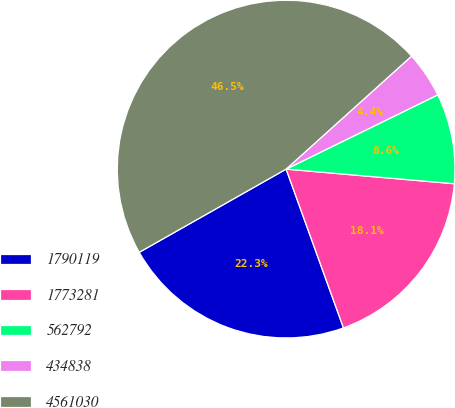<chart> <loc_0><loc_0><loc_500><loc_500><pie_chart><fcel>1790119<fcel>1773281<fcel>562792<fcel>434838<fcel>4561030<nl><fcel>22.31%<fcel>18.1%<fcel>8.63%<fcel>4.42%<fcel>46.53%<nl></chart> 